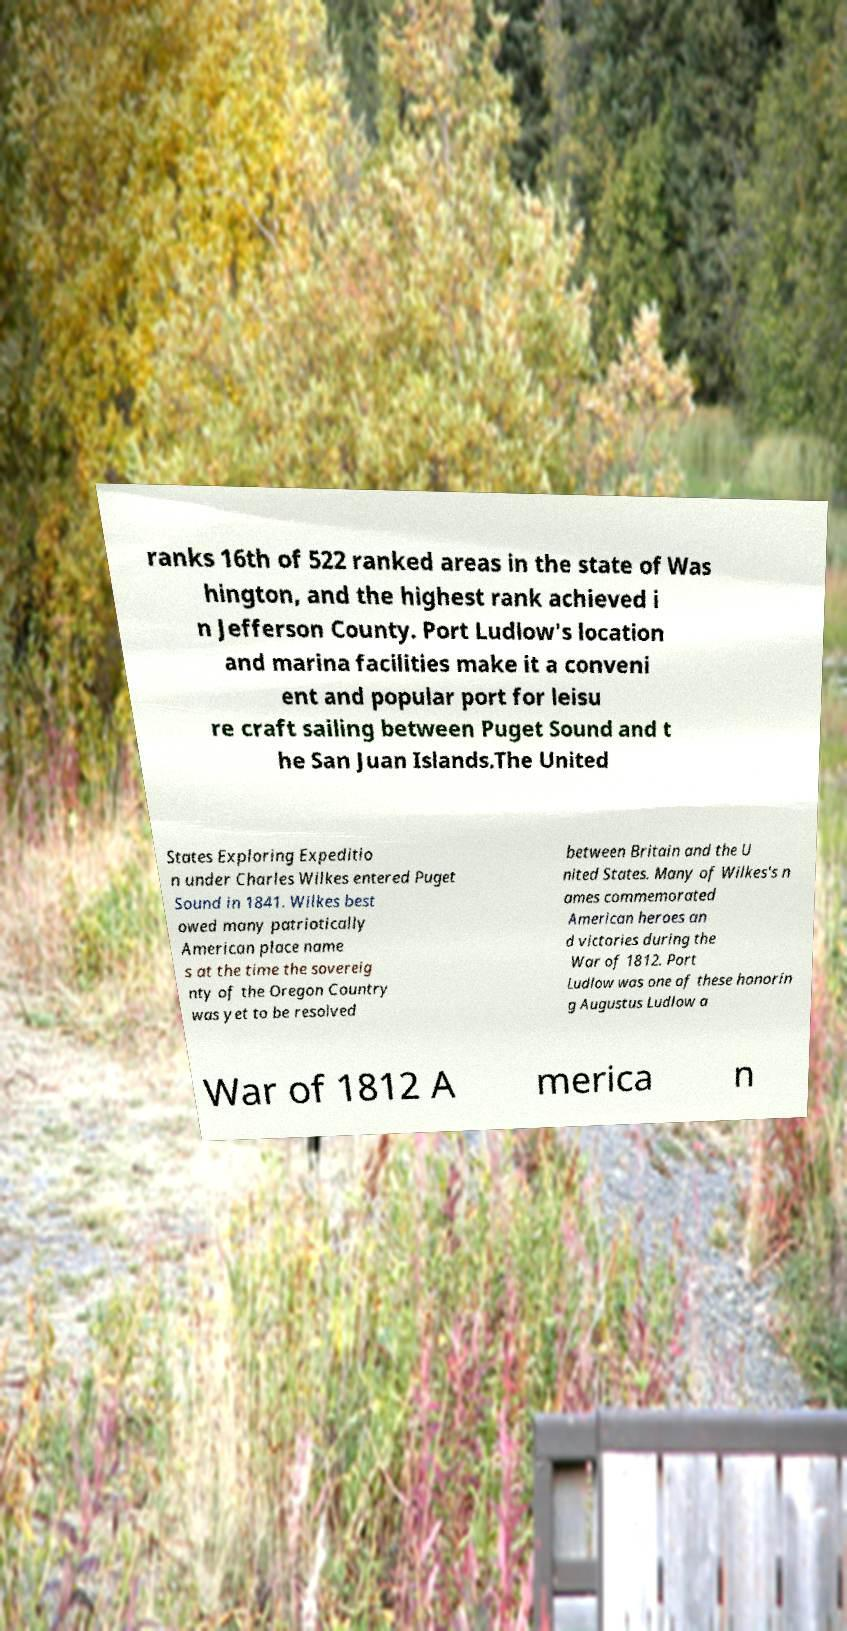Can you accurately transcribe the text from the provided image for me? ranks 16th of 522 ranked areas in the state of Was hington, and the highest rank achieved i n Jefferson County. Port Ludlow's location and marina facilities make it a conveni ent and popular port for leisu re craft sailing between Puget Sound and t he San Juan Islands.The United States Exploring Expeditio n under Charles Wilkes entered Puget Sound in 1841. Wilkes best owed many patriotically American place name s at the time the sovereig nty of the Oregon Country was yet to be resolved between Britain and the U nited States. Many of Wilkes's n ames commemorated American heroes an d victories during the War of 1812. Port Ludlow was one of these honorin g Augustus Ludlow a War of 1812 A merica n 